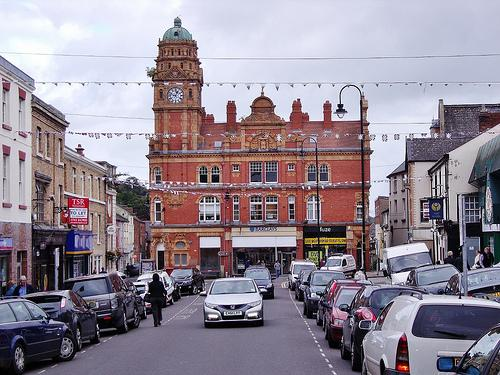Compose a sentence describing the main focus and activity taking place in the image. A group of people and cars interact on a busy street, with various objects like buildings, signs, and trees surrounding them. Write a brief interpretation of the main subjects and occurrences in the image. The photo portrays a dynamic city street where individuals walk among moving cars and an array of buildings, signs, and trees. Create a concise description of the key subjects and events taking place in the image. People stroll down a lively street filled with various cars, buildings, signs, and trees, creating a dynamic urban atmosphere. Construct a short statement summarizing the key aspects and occurrences in the image. The photo showcases a vibrant street environment with people on foot, moving cars, and an interesting assortment of buildings, signs, and trees. Express the principal objects and activities captured in the picture with a clear and concise statement. In the image, a bustling street scene unfolds with people walking and cars driving near various buildings, signs, and trees. Provide a brief analysis of the main components and activities occurring within the picture. The image depicts an active street scene with people walking, cars going by, and a visually engaging backdrop of buildings, signs, and foliage. Describe the central subjects and their actions in the image, along with some of the noticeable surroundings. On a busy street, individuals walk by while cars drive past, and the scene is punctuated by colorful buildings, signs, and trees. Summarize the main elements and happenings of the photo in a single sentence. The image captures a bustling street scene with cars and pedestrians navigating their surroundings amidst buildings, signs, and trees. Write a brief overview of the primary objects and actions in the image. The image features people walking and cars driving on a street, with buildings, signs, and trees providing a colorful and detailed backdrop. Compose a succinct explanation of the primary subjects and actions happening in the image. Pedestrians and vehicles interact on a lively street, surrounded by a diverse array of buildings, signs, and trees. 